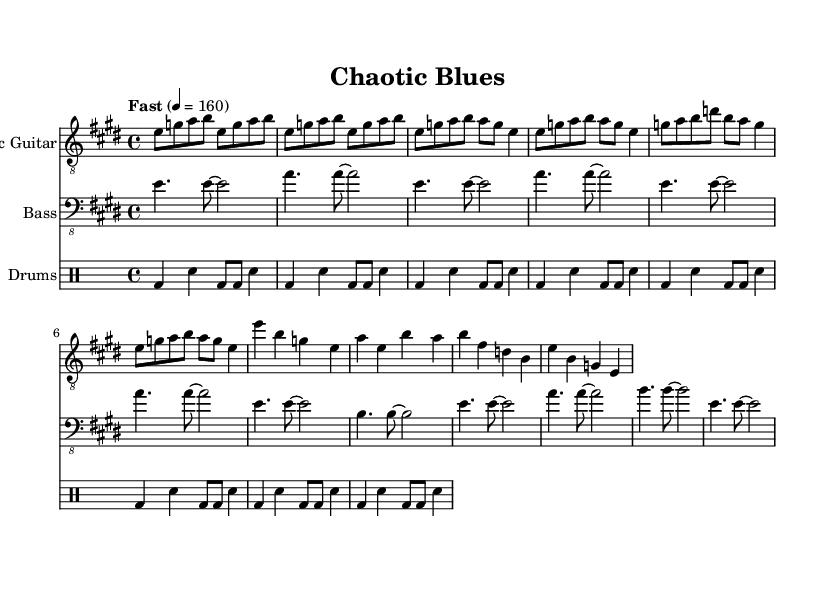What is the key signature of this music? The key signature indicates E major, which contains four sharps (F#, C#, G#, D#). This is confirmed by looking at the key signature at the beginning of the staff.
Answer: E major What is the time signature used in the piece? The time signature at the beginning shows 4/4, meaning there are four beats per measure and the quarter note gets one beat. This can be identified by examining the notation at the start of the score.
Answer: 4/4 What is the tempo marking for this piece? The tempo marking is indicated as "Fast" with a metronome value of 160, which describes the speed at which the piece should be played, virtually found next to the global settings.
Answer: Fast How many measures are present in the intro section? The intro section has 4 measures, as indicated by the repeated sequences and grouping of notes shown in the sheet music. By counting the measures represented by the notations of electric guitar and bass guitar during the intro.
Answer: 4 What is the primary rhythm pattern used in the drum part? The drum part uses a pattern consisting of bass drum (bd) on beats one and three, with snare drum (sn) on beats two and four, plus additional bass drum hits. This is determined by analyzing the drum notation in the score overall.
Answer: Bass and snare What theme of the song can be identified through the chorus section? The chorus section prominently features the chord progression E - A - B, common in electric blues. This can be recognized by reviewing the notes and structure of the chorus in the score, indicative of electric blues forms.
Answer: E - A - B What instrument plays in the highest register? The electric guitar plays in the highest register, as indicated by its treble clef notation which typically portrays higher pitches compared to the bass guitar and drums. This can be confirmed by looking at the clefs and pitches of the instruments in the score.
Answer: Electric Guitar 